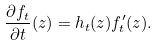<formula> <loc_0><loc_0><loc_500><loc_500>\frac { \partial f _ { t } } { \partial t } ( z ) = h _ { t } ( z ) f _ { t } ^ { \prime } ( z ) .</formula> 